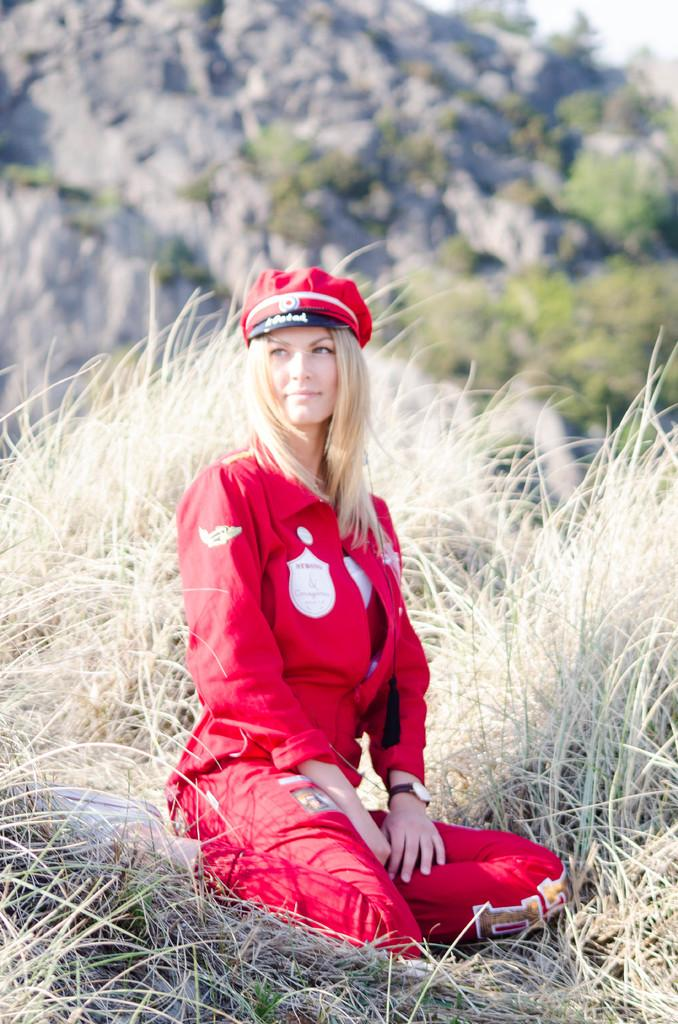Who is present in the image? There is a woman in the image. What is the woman doing in the image? The woman is sitting on the grass. What type of string is the woman holding in the image? There is no string present in the image; the woman is simply sitting on the grass. 